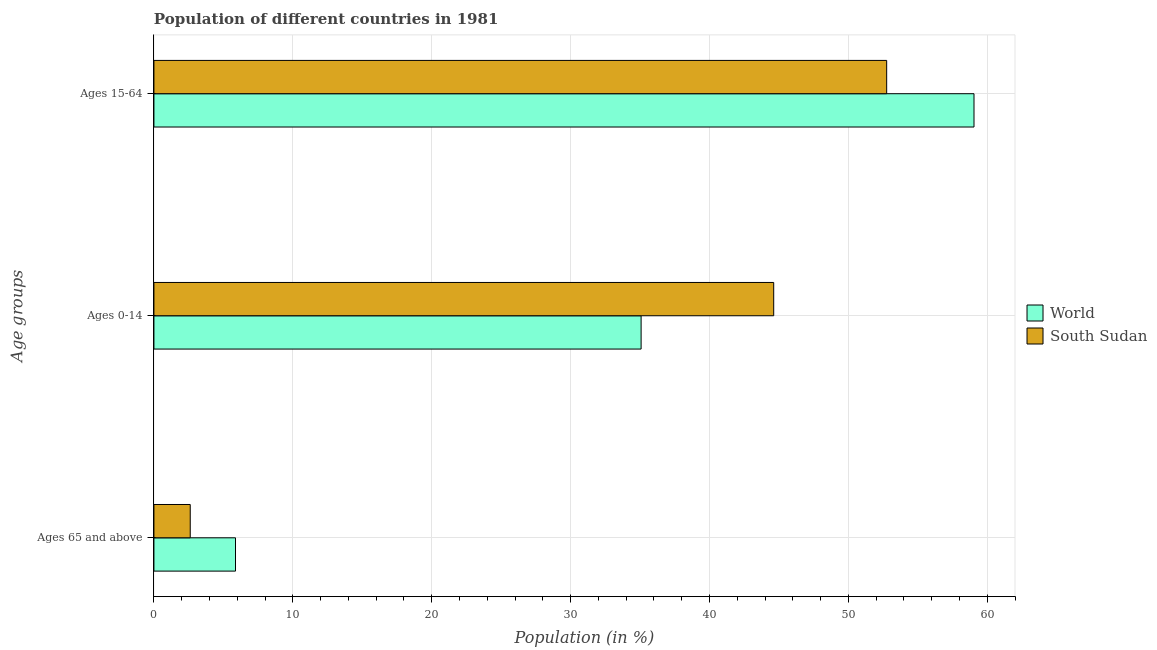Are the number of bars per tick equal to the number of legend labels?
Provide a short and direct response. Yes. Are the number of bars on each tick of the Y-axis equal?
Provide a short and direct response. Yes. How many bars are there on the 1st tick from the top?
Give a very brief answer. 2. How many bars are there on the 2nd tick from the bottom?
Your answer should be very brief. 2. What is the label of the 3rd group of bars from the top?
Provide a succinct answer. Ages 65 and above. What is the percentage of population within the age-group 0-14 in World?
Provide a succinct answer. 35.08. Across all countries, what is the maximum percentage of population within the age-group 0-14?
Keep it short and to the point. 44.63. Across all countries, what is the minimum percentage of population within the age-group of 65 and above?
Provide a short and direct response. 2.61. In which country was the percentage of population within the age-group 15-64 minimum?
Make the answer very short. South Sudan. What is the total percentage of population within the age-group 0-14 in the graph?
Your answer should be very brief. 79.7. What is the difference between the percentage of population within the age-group 15-64 in South Sudan and that in World?
Provide a succinct answer. -6.29. What is the difference between the percentage of population within the age-group 0-14 in World and the percentage of population within the age-group of 65 and above in South Sudan?
Your response must be concise. 32.46. What is the average percentage of population within the age-group 0-14 per country?
Ensure brevity in your answer.  39.85. What is the difference between the percentage of population within the age-group of 65 and above and percentage of population within the age-group 15-64 in South Sudan?
Your answer should be compact. -50.15. In how many countries, is the percentage of population within the age-group 15-64 greater than 28 %?
Give a very brief answer. 2. What is the ratio of the percentage of population within the age-group 0-14 in World to that in South Sudan?
Your response must be concise. 0.79. Is the percentage of population within the age-group 0-14 in World less than that in South Sudan?
Make the answer very short. Yes. Is the difference between the percentage of population within the age-group of 65 and above in South Sudan and World greater than the difference between the percentage of population within the age-group 0-14 in South Sudan and World?
Offer a terse response. No. What is the difference between the highest and the second highest percentage of population within the age-group 15-64?
Your answer should be compact. 6.29. What is the difference between the highest and the lowest percentage of population within the age-group 0-14?
Keep it short and to the point. 9.55. In how many countries, is the percentage of population within the age-group 15-64 greater than the average percentage of population within the age-group 15-64 taken over all countries?
Provide a short and direct response. 1. Is the sum of the percentage of population within the age-group 15-64 in World and South Sudan greater than the maximum percentage of population within the age-group 0-14 across all countries?
Keep it short and to the point. Yes. What does the 1st bar from the top in Ages 15-64 represents?
Make the answer very short. South Sudan. How many countries are there in the graph?
Your response must be concise. 2. What is the difference between two consecutive major ticks on the X-axis?
Your answer should be compact. 10. Does the graph contain any zero values?
Provide a short and direct response. No. How are the legend labels stacked?
Offer a very short reply. Vertical. What is the title of the graph?
Provide a succinct answer. Population of different countries in 1981. What is the label or title of the X-axis?
Your response must be concise. Population (in %). What is the label or title of the Y-axis?
Give a very brief answer. Age groups. What is the Population (in %) of World in Ages 65 and above?
Your answer should be very brief. 5.87. What is the Population (in %) in South Sudan in Ages 65 and above?
Your answer should be very brief. 2.61. What is the Population (in %) in World in Ages 0-14?
Make the answer very short. 35.08. What is the Population (in %) of South Sudan in Ages 0-14?
Offer a very short reply. 44.63. What is the Population (in %) in World in Ages 15-64?
Make the answer very short. 59.05. What is the Population (in %) of South Sudan in Ages 15-64?
Offer a very short reply. 52.76. Across all Age groups, what is the maximum Population (in %) in World?
Give a very brief answer. 59.05. Across all Age groups, what is the maximum Population (in %) in South Sudan?
Provide a succinct answer. 52.76. Across all Age groups, what is the minimum Population (in %) of World?
Give a very brief answer. 5.87. Across all Age groups, what is the minimum Population (in %) of South Sudan?
Offer a terse response. 2.61. What is the total Population (in %) in World in the graph?
Give a very brief answer. 100. What is the difference between the Population (in %) in World in Ages 65 and above and that in Ages 0-14?
Keep it short and to the point. -29.2. What is the difference between the Population (in %) of South Sudan in Ages 65 and above and that in Ages 0-14?
Ensure brevity in your answer.  -42.01. What is the difference between the Population (in %) in World in Ages 65 and above and that in Ages 15-64?
Provide a succinct answer. -53.17. What is the difference between the Population (in %) in South Sudan in Ages 65 and above and that in Ages 15-64?
Offer a terse response. -50.15. What is the difference between the Population (in %) in World in Ages 0-14 and that in Ages 15-64?
Make the answer very short. -23.97. What is the difference between the Population (in %) in South Sudan in Ages 0-14 and that in Ages 15-64?
Your answer should be very brief. -8.13. What is the difference between the Population (in %) of World in Ages 65 and above and the Population (in %) of South Sudan in Ages 0-14?
Provide a short and direct response. -38.75. What is the difference between the Population (in %) of World in Ages 65 and above and the Population (in %) of South Sudan in Ages 15-64?
Your answer should be compact. -46.89. What is the difference between the Population (in %) of World in Ages 0-14 and the Population (in %) of South Sudan in Ages 15-64?
Make the answer very short. -17.68. What is the average Population (in %) of World per Age groups?
Ensure brevity in your answer.  33.33. What is the average Population (in %) of South Sudan per Age groups?
Ensure brevity in your answer.  33.33. What is the difference between the Population (in %) of World and Population (in %) of South Sudan in Ages 65 and above?
Give a very brief answer. 3.26. What is the difference between the Population (in %) of World and Population (in %) of South Sudan in Ages 0-14?
Keep it short and to the point. -9.55. What is the difference between the Population (in %) in World and Population (in %) in South Sudan in Ages 15-64?
Your answer should be compact. 6.29. What is the ratio of the Population (in %) in World in Ages 65 and above to that in Ages 0-14?
Ensure brevity in your answer.  0.17. What is the ratio of the Population (in %) in South Sudan in Ages 65 and above to that in Ages 0-14?
Give a very brief answer. 0.06. What is the ratio of the Population (in %) in World in Ages 65 and above to that in Ages 15-64?
Provide a succinct answer. 0.1. What is the ratio of the Population (in %) in South Sudan in Ages 65 and above to that in Ages 15-64?
Your answer should be very brief. 0.05. What is the ratio of the Population (in %) of World in Ages 0-14 to that in Ages 15-64?
Provide a short and direct response. 0.59. What is the ratio of the Population (in %) of South Sudan in Ages 0-14 to that in Ages 15-64?
Your answer should be compact. 0.85. What is the difference between the highest and the second highest Population (in %) in World?
Provide a short and direct response. 23.97. What is the difference between the highest and the second highest Population (in %) in South Sudan?
Give a very brief answer. 8.13. What is the difference between the highest and the lowest Population (in %) in World?
Keep it short and to the point. 53.17. What is the difference between the highest and the lowest Population (in %) in South Sudan?
Your response must be concise. 50.15. 